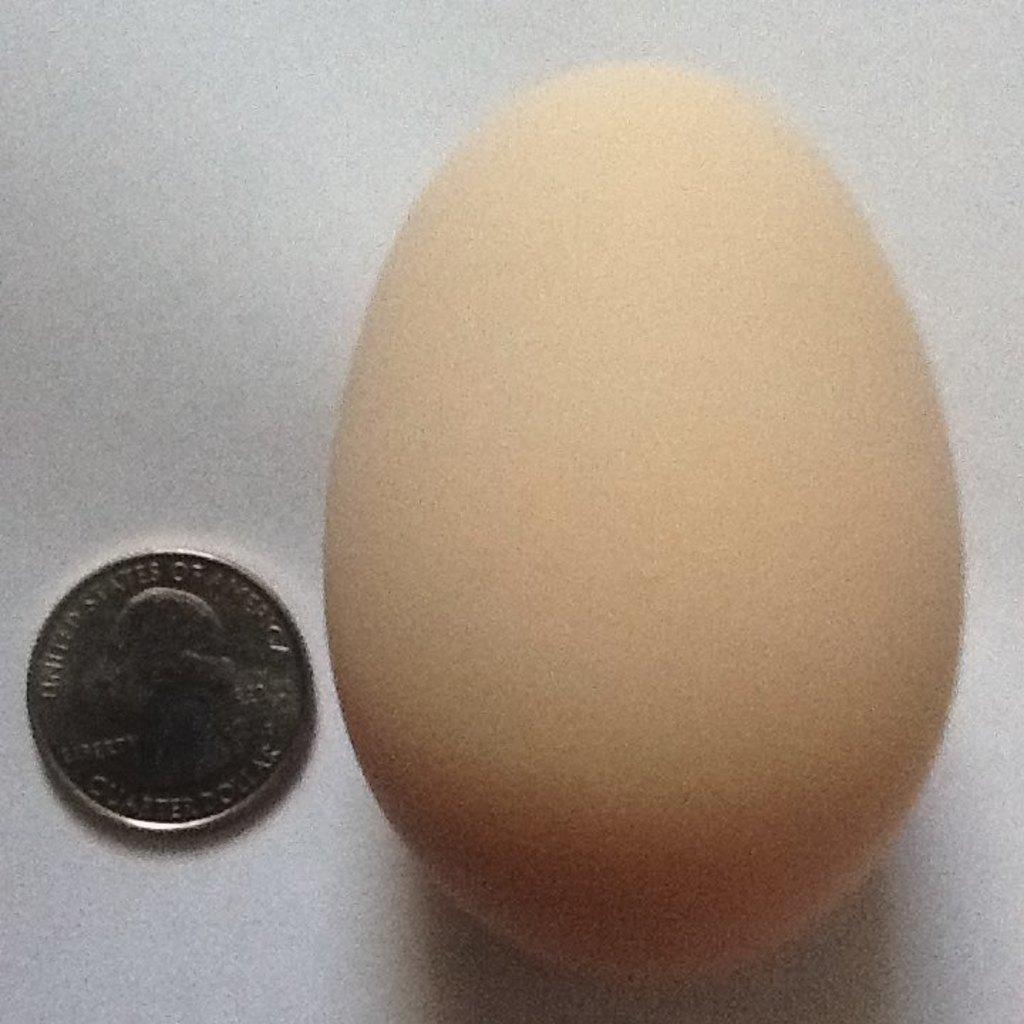How would you summarize this image in a sentence or two? In this picture we can see an egg and a coin on an object. 